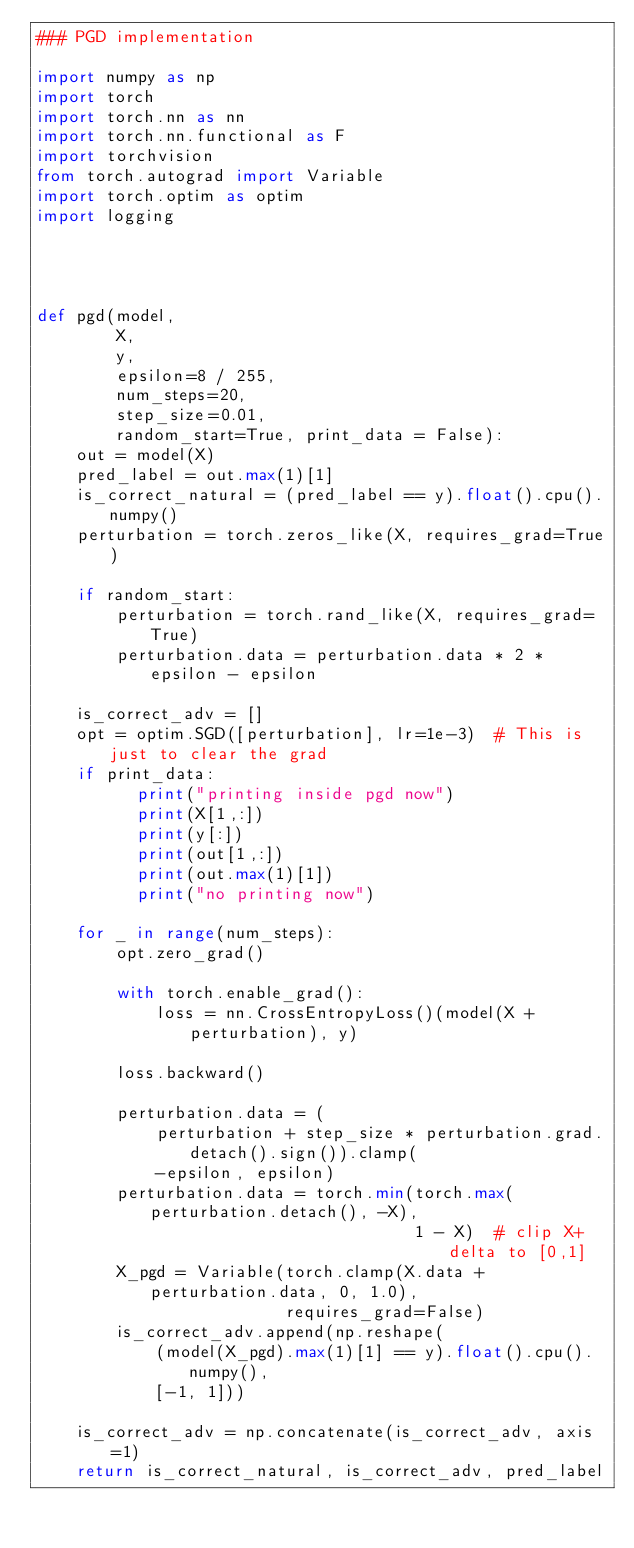<code> <loc_0><loc_0><loc_500><loc_500><_Python_>### PGD implementation

import numpy as np
import torch
import torch.nn as nn
import torch.nn.functional as F
import torchvision
from torch.autograd import Variable
import torch.optim as optim
import logging




def pgd(model,
        X,
        y,
        epsilon=8 / 255,
        num_steps=20,
        step_size=0.01,
        random_start=True, print_data = False):
    out = model(X)
    pred_label = out.max(1)[1]
    is_correct_natural = (pred_label == y).float().cpu().numpy()
    perturbation = torch.zeros_like(X, requires_grad=True)

    if random_start:
        perturbation = torch.rand_like(X, requires_grad=True)
        perturbation.data = perturbation.data * 2 * epsilon - epsilon

    is_correct_adv = []
    opt = optim.SGD([perturbation], lr=1e-3)  # This is just to clear the grad
    if print_data:
          print("printing inside pgd now")
          print(X[1,:])
          print(y[:])
          print(out[1,:])
          print(out.max(1)[1])
          print("no printing now")
          
    for _ in range(num_steps):
        opt.zero_grad()

        with torch.enable_grad():
            loss = nn.CrossEntropyLoss()(model(X + perturbation), y)

        loss.backward()

        perturbation.data = (
            perturbation + step_size * perturbation.grad.detach().sign()).clamp(
            -epsilon, epsilon)
        perturbation.data = torch.min(torch.max(perturbation.detach(), -X),
                                      1 - X)  # clip X+delta to [0,1]
        X_pgd = Variable(torch.clamp(X.data + perturbation.data, 0, 1.0),
                         requires_grad=False)
        is_correct_adv.append(np.reshape(
            (model(X_pgd).max(1)[1] == y).float().cpu().numpy(),
            [-1, 1]))

    is_correct_adv = np.concatenate(is_correct_adv, axis=1)
    return is_correct_natural, is_correct_adv, pred_label


</code> 